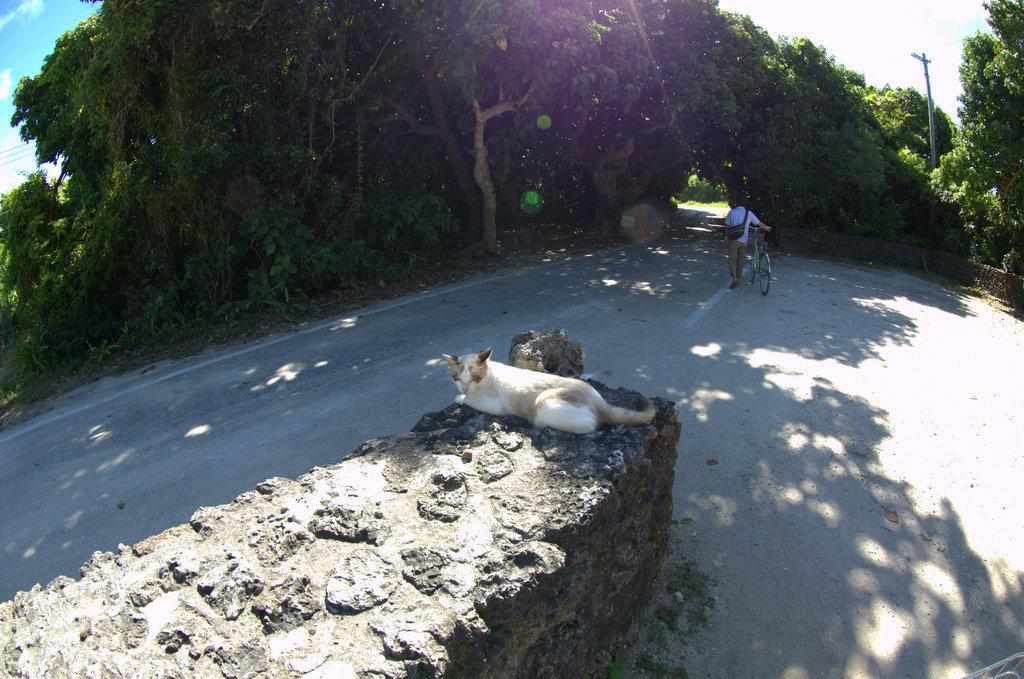In one or two sentences, can you explain what this image depicts? In this image, we can see a cat is laying on the wall. Here a person is holding a bicycle and walking on the road. Top of the image, we can see so many trees, plants, pole and sky. 